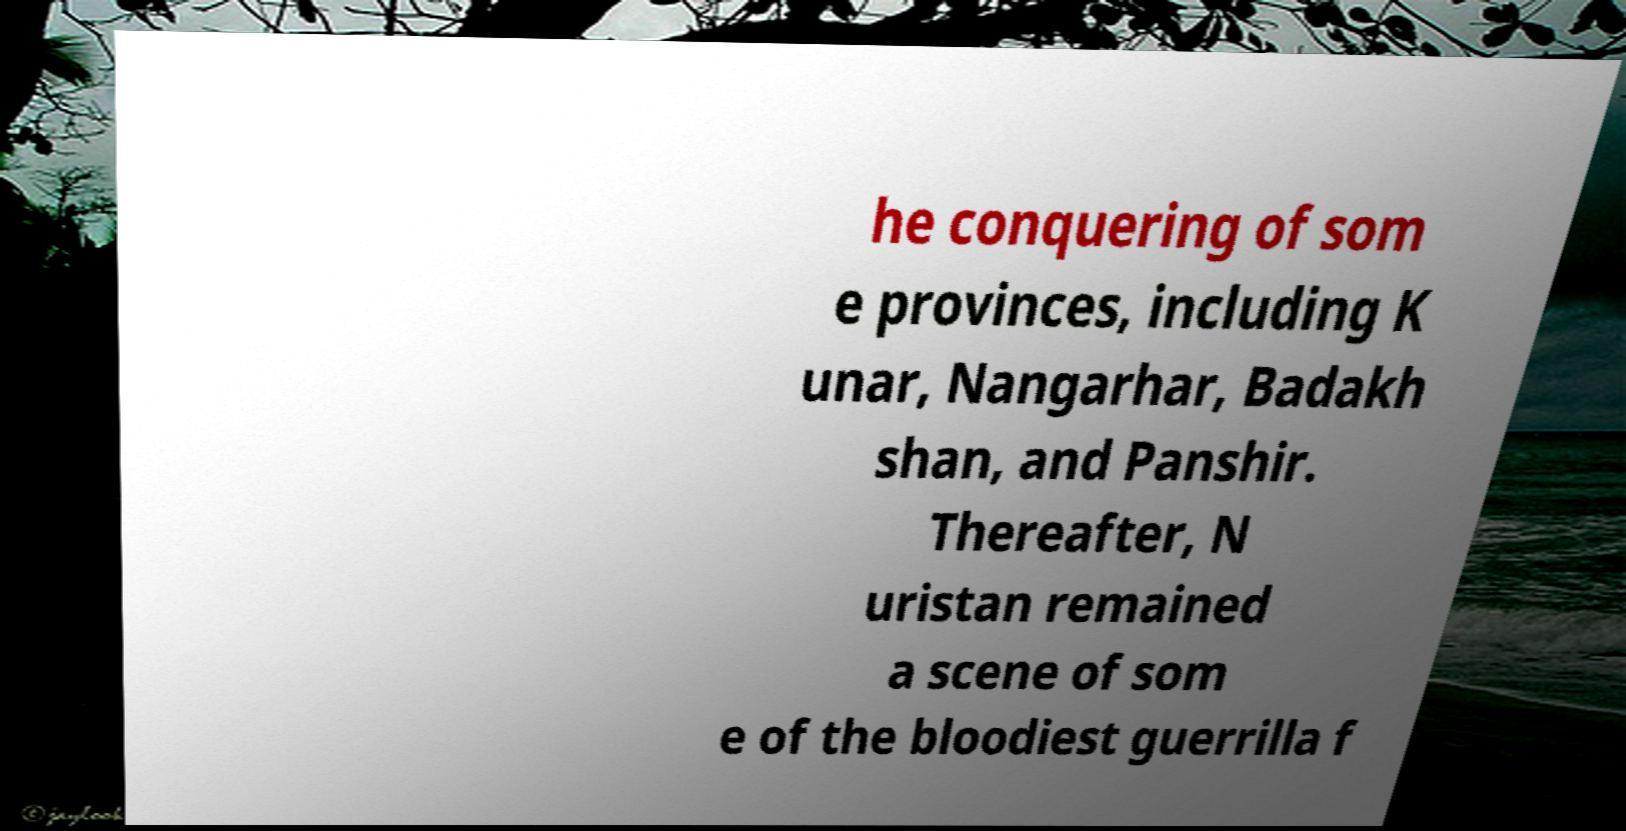I need the written content from this picture converted into text. Can you do that? he conquering of som e provinces, including K unar, Nangarhar, Badakh shan, and Panshir. Thereafter, N uristan remained a scene of som e of the bloodiest guerrilla f 